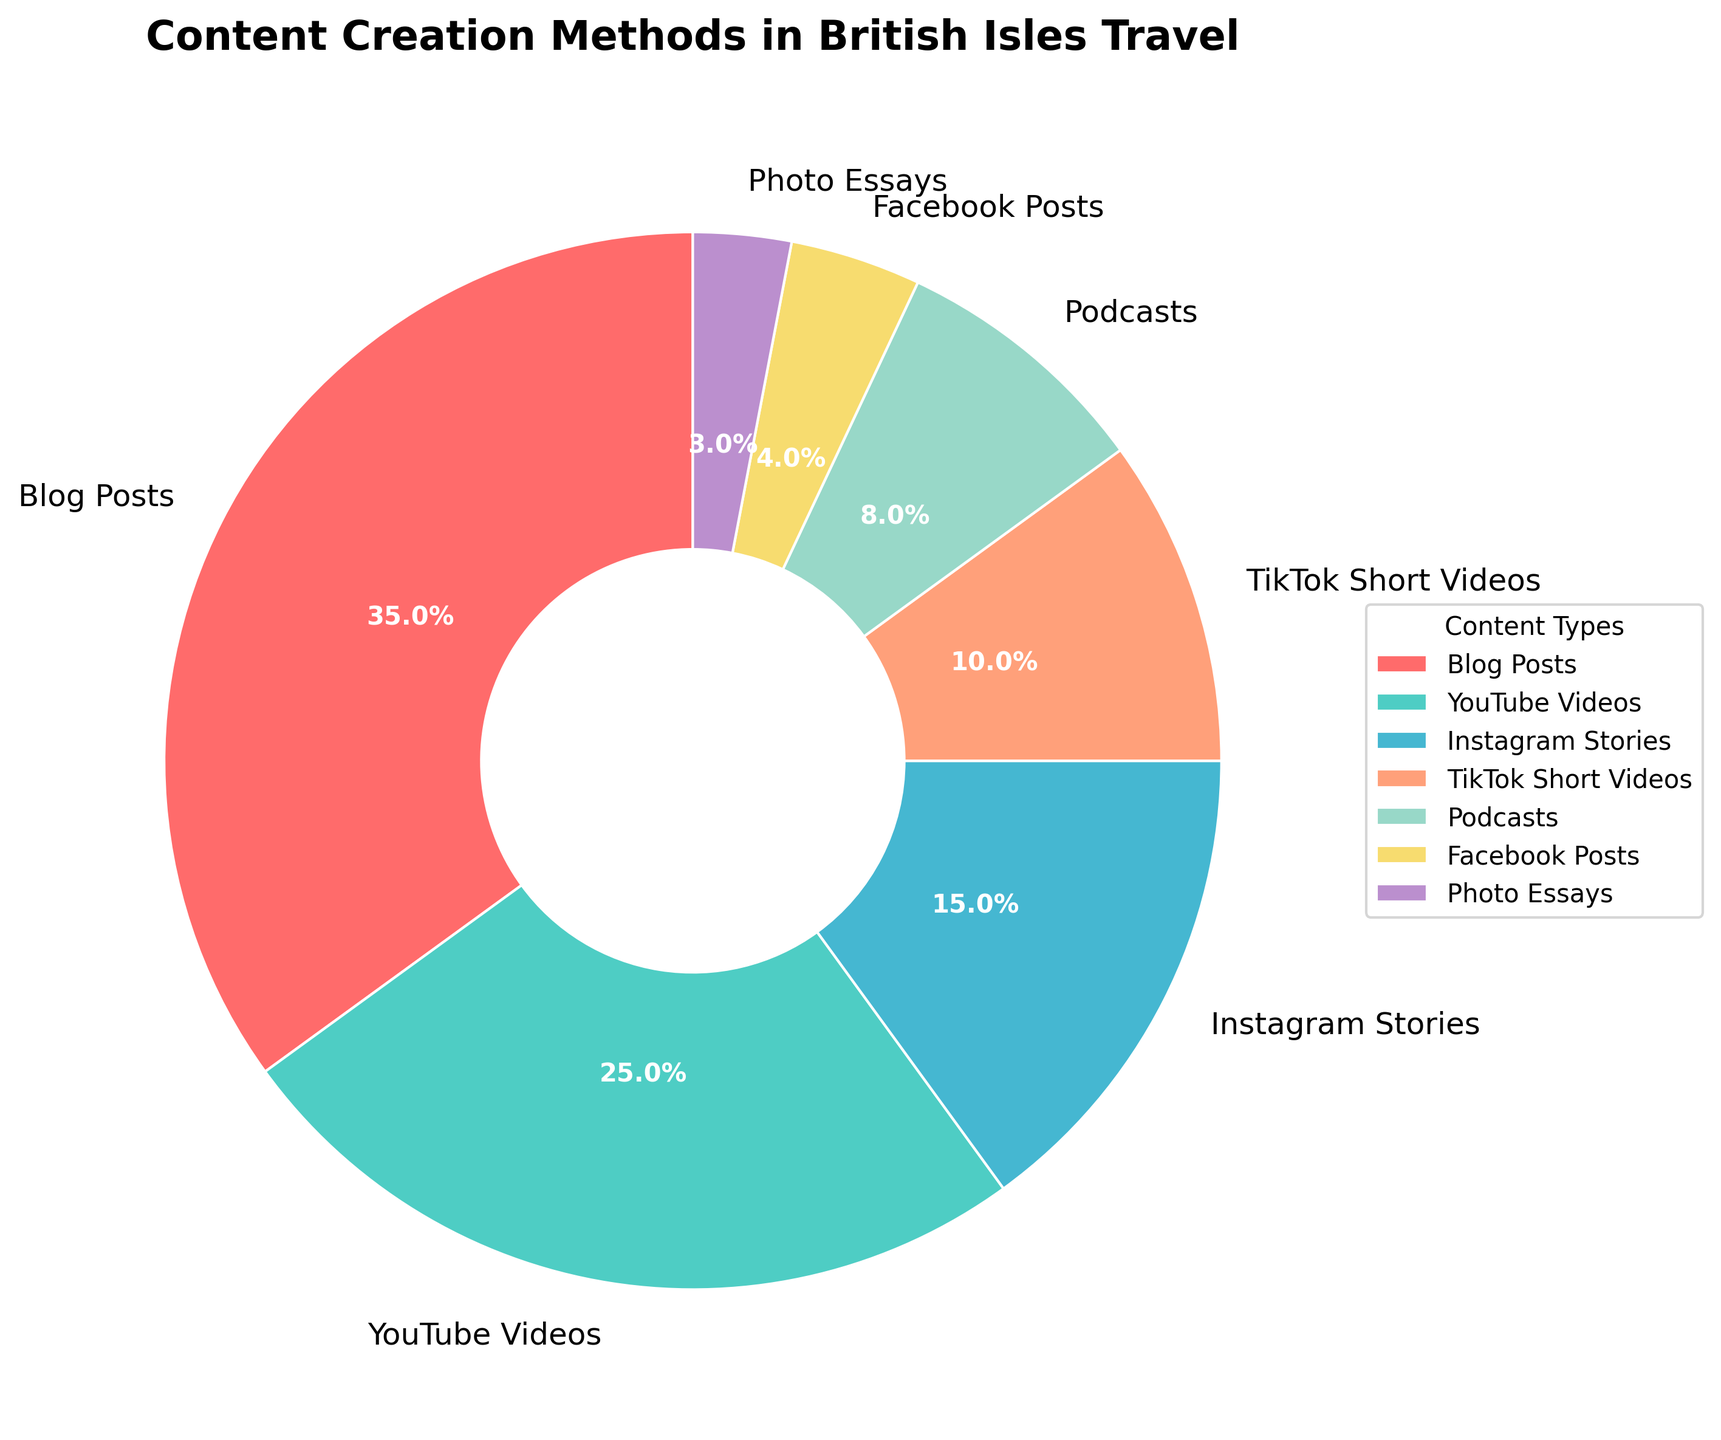What is the largest content creation method by percentage? The pie chart shows different content types with corresponding percentages. The largest segment is Blog Posts at 35%.
Answer: Blog Posts Which content type has a smaller percentage, Podcasts or Facebook Posts? Comparing the sizes of the segments, Podcasts have 8% whereas Facebook Posts have 4%. Facebook Posts have a smaller percentage.
Answer: Facebook Posts What is the combined percentage of YouTube Videos and TikTok Short Videos? Adding the percentages of YouTube Videos (25%) and TikTok Short Videos (10%) gives 25 + 10 = 35%.
Answer: 35% Which content type is represented by the blue segment? Looking at the pie chart, the blue segment represents Instagram Stories, which has a percentage of 15%.
Answer: Instagram Stories Are there more Instagram Stories or Podcasts? By comparing the two segments, Instagram Stories have 15% whereas Podcasts have 8%. Therefore, there are more Instagram Stories.
Answer: Instagram Stories What is the difference in percentage between the highest and lowest content types? The highest percentage is Blog Posts at 35%, and the lowest is Photo Essays at 3%. The difference is 35 - 3 = 32%.
Answer: 32% How does the percentage of TikTok Short Videos compare to Instagram Stories? TikTok Short Videos have 10% and Instagram Stories have 15%. TikTok Short Videos have 5% less than Instagram Stories.
Answer: 5% less Which category is the smallest by percentage, and what percentage does it represent? The smallest segment in the pie chart is Photo Essays, which represent 3% of the content types.
Answer: Photo Essays, 3% What is the total percentage of content creation methods that require video production (YouTube Videos and TikTok Short Videos)? Adding the percentages for YouTube Videos (25%) and TikTok Short Videos (10%) results in 25 + 10 = 35%.
Answer: 35% If you remove Blog Posts from the chart, what would be the new largest content type? Without Blog Posts (35%), the next largest segment is YouTube Videos at 25%.
Answer: YouTube Videos 